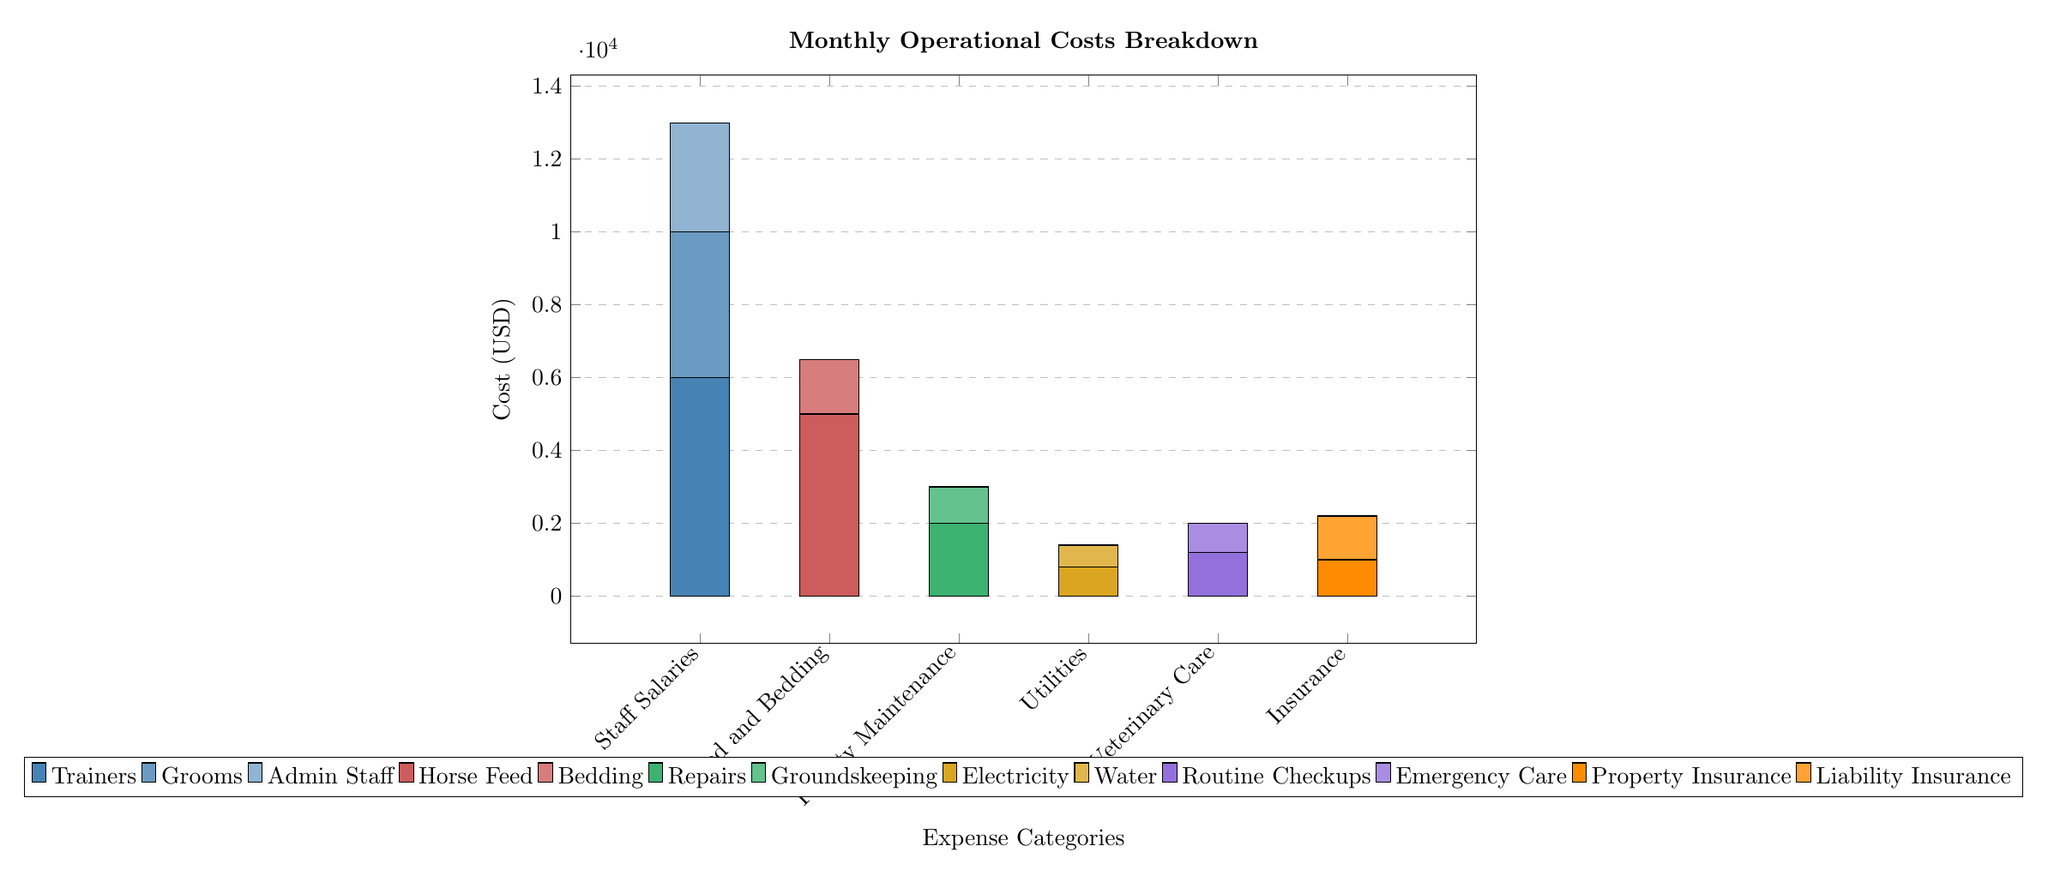What is the total cost for Staff Salaries? To find the total cost for Staff Salaries, I need to look at the stacked bar corresponding to "Staff Salaries" and add the values shown in the different shades. The values are 6000, 4000, and 3000. Adding them together gives 6000 + 4000 + 3000 = 13000.
Answer: 13000 What is the highest monthly expense category? By examining the bars in the graph, the highest expense category has the tallest bar, which is "Staff Salaries." The corresponding value is 13000.
Answer: Staff Salaries What are the total expenses for Feed and Bedding? I will review the stacked bar associated with "Feed and Bedding." It shows values of 5000 and 1500. Adding these amounts gives 5000 + 1500 = 6500.
Answer: 6500 Which category has the lowest total expense? Looking at the bars representing different expense categories, "Facility Maintenance" and "Utilities" each have their tallest bars at 2000 and 800 respectively, but since both are significantly lower than others, I focus on the lowest values. The lowest thus is clearly "Utilities," with a total of 800.
Answer: Utilities How much is spent on Veterinary Care in total? To find the total for Veterinary Care, I will look at the corresponding bar. It has values of 1200 and 800. Adding these provides the total: 1200 + 800 = 2000.
Answer: 2000 What percentage of the total monthly expenses is represented by Insurance? The total monthly expenses are the sum of all expenses: 13000 (Salaries) + 6500 (Feed) + 3000 (Maintenance) + 1400 (Utilities) + 2000 (Veterinary Care) + 2200 (Insurance) = 32000. For Insurance, the total costs are 2200. The percentage can be calculated as (2200 / 32000) * 100 = 6.875%.
Answer: 6.875% If the cost for Electricity is added, how would that impact the total expense? The current total expenses amount to 32000. If I include an additional cost for Electricity (let's say it's 1000), the new total would be 32000 + 1000 = 33000. Hence, the overall increase is 1000.
Answer: Increase by 1000 What is the total monthly expense for Facility Maintenance? The Facility Maintenance bar shows amounts of 2000 and 1000. Adding these two gives a total of 3000 for Facility Maintenance.
Answer: 3000 